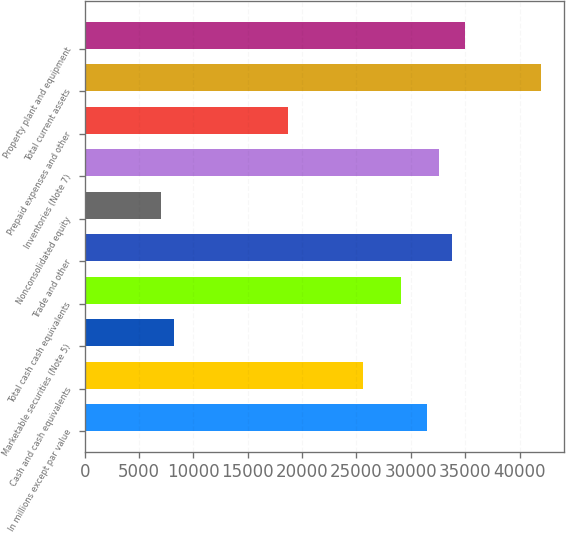Convert chart. <chart><loc_0><loc_0><loc_500><loc_500><bar_chart><fcel>In millions except par value<fcel>Cash and cash equivalents<fcel>Marketable securities (Note 5)<fcel>Total cash cash equivalents<fcel>Trade and other<fcel>Nonconsolidated equity<fcel>Inventories (Note 7)<fcel>Prepaid expenses and other<fcel>Total current assets<fcel>Property plant and equipment<nl><fcel>31466.2<fcel>25643.2<fcel>8174.2<fcel>29137<fcel>33795.4<fcel>7009.6<fcel>32630.8<fcel>18655.6<fcel>41947.6<fcel>34960<nl></chart> 